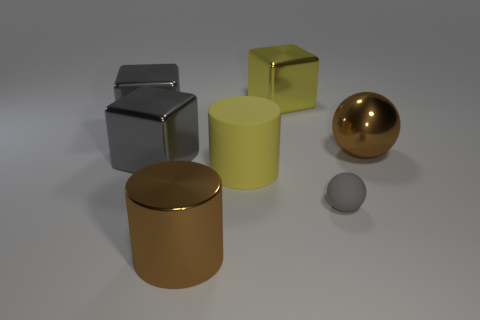There is a metallic block to the right of the yellow rubber cylinder; is its color the same as the big matte thing?
Provide a succinct answer. Yes. How many blocks are the same color as the small rubber thing?
Make the answer very short. 2. How many other objects are there of the same color as the small rubber ball?
Provide a succinct answer. 2. What is the color of the small rubber thing?
Keep it short and to the point. Gray. How many yellow matte cylinders are in front of the large shiny block right of the brown object that is on the left side of the yellow cube?
Provide a succinct answer. 1. There is a gray sphere; are there any large brown things left of it?
Provide a short and direct response. Yes. What number of cylinders have the same material as the tiny gray thing?
Give a very brief answer. 1. How many things are either metal spheres or gray metal things?
Your response must be concise. 3. Is there a green object?
Your answer should be very brief. No. What material is the small ball that is in front of the metal object that is right of the large cube to the right of the big yellow cylinder?
Make the answer very short. Rubber. 